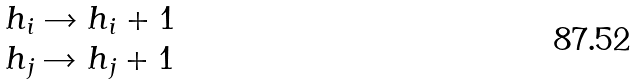Convert formula to latex. <formula><loc_0><loc_0><loc_500><loc_500>\begin{array} { l } h _ { i } \rightarrow h _ { i } + 1 \\ h _ { j } \rightarrow h _ { j } + 1 \end{array}</formula> 